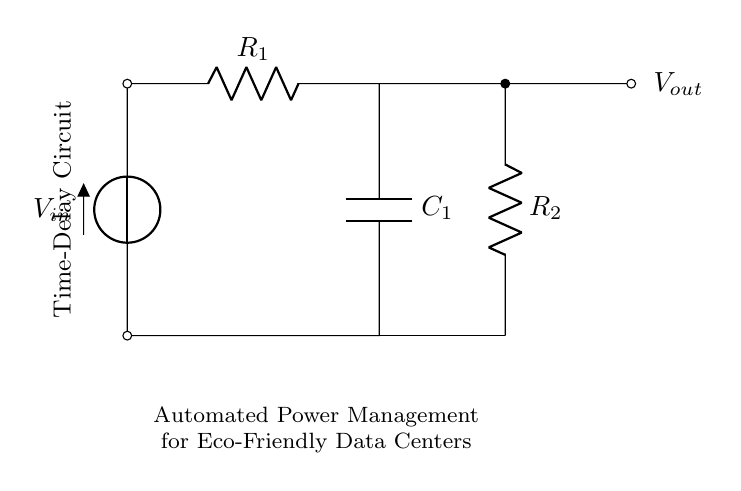What is the input voltage of the circuit? The input voltage is labeled as V in the diagram. This is depicted as the first component in the circuit which connects to the resistor R1 at the top left corner.
Answer: V in What components are present in the circuit? The circuit includes two resistors (R1, R2) and one capacitor (C1). Each component is labeled and connected to form the circuit.
Answer: Resistors and capacitor What is the role of the capacitor in this circuit? The capacitor C1 is used to create a time-delay effect. It charges through R1 and discharges, influencing the timing for the automated power management.
Answer: Time-delay What is the output location of this circuit? The output voltage is marked as V out and is located to the right of the second resistor R2. It is connected through a short to indicate the output point of the circuit.
Answer: V out How does the time delay impact eco-friendly data centers? The time delay enables the circuit to manage power consumption effectively, allowing for reduced energy waste during low-demand periods in eco-friendly data centers.
Answer: Reduces energy waste What is the total resistance when R1 and R2 are in parallel? R1 is in series with the capacitor, while R2 is also in series with the output. Since they are not in parallel, calculating total resistance is unnecessary. Hence, it is considered solely in terms of R1’s series effect with the capacitor.
Answer: Not applicable What is the function of the automatic power management in this context? The function is to optimize electricity use based on load patterns, helping to reduce carbon footprint in data center operations.
Answer: Optimize electricity use 